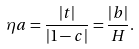<formula> <loc_0><loc_0><loc_500><loc_500>\eta a = \frac { | t | } { | 1 - c | } = \frac { | b | } { H } .</formula> 